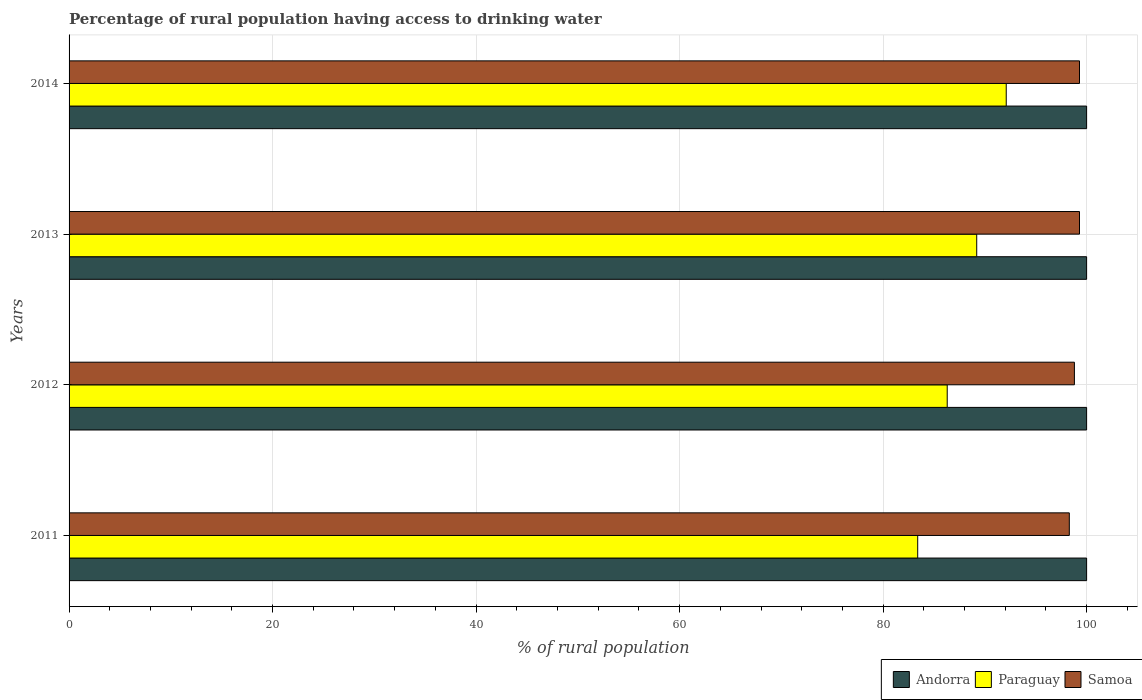How many different coloured bars are there?
Your response must be concise. 3. Are the number of bars per tick equal to the number of legend labels?
Your answer should be compact. Yes. How many bars are there on the 4th tick from the bottom?
Provide a short and direct response. 3. In how many cases, is the number of bars for a given year not equal to the number of legend labels?
Offer a very short reply. 0. What is the percentage of rural population having access to drinking water in Samoa in 2014?
Your answer should be very brief. 99.3. Across all years, what is the maximum percentage of rural population having access to drinking water in Samoa?
Ensure brevity in your answer.  99.3. Across all years, what is the minimum percentage of rural population having access to drinking water in Samoa?
Provide a succinct answer. 98.3. In which year was the percentage of rural population having access to drinking water in Andorra maximum?
Make the answer very short. 2011. What is the total percentage of rural population having access to drinking water in Samoa in the graph?
Your answer should be very brief. 395.7. What is the difference between the percentage of rural population having access to drinking water in Samoa in 2011 and the percentage of rural population having access to drinking water in Andorra in 2014?
Offer a terse response. -1.7. In the year 2011, what is the difference between the percentage of rural population having access to drinking water in Andorra and percentage of rural population having access to drinking water in Samoa?
Your answer should be very brief. 1.7. What is the ratio of the percentage of rural population having access to drinking water in Samoa in 2013 to that in 2014?
Provide a succinct answer. 1. Is the percentage of rural population having access to drinking water in Samoa in 2011 less than that in 2012?
Keep it short and to the point. Yes. Is the difference between the percentage of rural population having access to drinking water in Andorra in 2012 and 2014 greater than the difference between the percentage of rural population having access to drinking water in Samoa in 2012 and 2014?
Provide a short and direct response. Yes. What is the difference between the highest and the second highest percentage of rural population having access to drinking water in Paraguay?
Provide a short and direct response. 2.9. In how many years, is the percentage of rural population having access to drinking water in Paraguay greater than the average percentage of rural population having access to drinking water in Paraguay taken over all years?
Make the answer very short. 2. Is the sum of the percentage of rural population having access to drinking water in Samoa in 2011 and 2012 greater than the maximum percentage of rural population having access to drinking water in Paraguay across all years?
Your response must be concise. Yes. What does the 1st bar from the top in 2013 represents?
Provide a short and direct response. Samoa. What does the 2nd bar from the bottom in 2011 represents?
Offer a very short reply. Paraguay. What is the difference between two consecutive major ticks on the X-axis?
Provide a short and direct response. 20. Are the values on the major ticks of X-axis written in scientific E-notation?
Your response must be concise. No. What is the title of the graph?
Your answer should be compact. Percentage of rural population having access to drinking water. Does "Haiti" appear as one of the legend labels in the graph?
Your answer should be very brief. No. What is the label or title of the X-axis?
Give a very brief answer. % of rural population. What is the label or title of the Y-axis?
Your answer should be compact. Years. What is the % of rural population in Paraguay in 2011?
Provide a short and direct response. 83.4. What is the % of rural population in Samoa in 2011?
Provide a succinct answer. 98.3. What is the % of rural population in Andorra in 2012?
Offer a terse response. 100. What is the % of rural population of Paraguay in 2012?
Keep it short and to the point. 86.3. What is the % of rural population in Samoa in 2012?
Your answer should be compact. 98.8. What is the % of rural population of Andorra in 2013?
Your response must be concise. 100. What is the % of rural population of Paraguay in 2013?
Offer a terse response. 89.2. What is the % of rural population in Samoa in 2013?
Offer a terse response. 99.3. What is the % of rural population in Paraguay in 2014?
Your answer should be compact. 92.1. What is the % of rural population of Samoa in 2014?
Provide a short and direct response. 99.3. Across all years, what is the maximum % of rural population in Paraguay?
Offer a terse response. 92.1. Across all years, what is the maximum % of rural population of Samoa?
Give a very brief answer. 99.3. Across all years, what is the minimum % of rural population in Andorra?
Keep it short and to the point. 100. Across all years, what is the minimum % of rural population of Paraguay?
Keep it short and to the point. 83.4. Across all years, what is the minimum % of rural population of Samoa?
Provide a succinct answer. 98.3. What is the total % of rural population in Paraguay in the graph?
Your response must be concise. 351. What is the total % of rural population in Samoa in the graph?
Provide a short and direct response. 395.7. What is the difference between the % of rural population in Samoa in 2011 and that in 2012?
Offer a very short reply. -0.5. What is the difference between the % of rural population of Andorra in 2011 and that in 2013?
Your answer should be compact. 0. What is the difference between the % of rural population in Samoa in 2011 and that in 2013?
Ensure brevity in your answer.  -1. What is the difference between the % of rural population in Andorra in 2011 and that in 2014?
Your response must be concise. 0. What is the difference between the % of rural population of Paraguay in 2012 and that in 2013?
Your response must be concise. -2.9. What is the difference between the % of rural population of Samoa in 2013 and that in 2014?
Provide a short and direct response. 0. What is the difference between the % of rural population of Paraguay in 2011 and the % of rural population of Samoa in 2012?
Your response must be concise. -15.4. What is the difference between the % of rural population of Paraguay in 2011 and the % of rural population of Samoa in 2013?
Your response must be concise. -15.9. What is the difference between the % of rural population in Andorra in 2011 and the % of rural population in Paraguay in 2014?
Offer a terse response. 7.9. What is the difference between the % of rural population of Andorra in 2011 and the % of rural population of Samoa in 2014?
Offer a very short reply. 0.7. What is the difference between the % of rural population of Paraguay in 2011 and the % of rural population of Samoa in 2014?
Your response must be concise. -15.9. What is the difference between the % of rural population in Andorra in 2012 and the % of rural population in Paraguay in 2013?
Ensure brevity in your answer.  10.8. What is the difference between the % of rural population of Andorra in 2012 and the % of rural population of Samoa in 2013?
Offer a very short reply. 0.7. What is the difference between the % of rural population of Paraguay in 2012 and the % of rural population of Samoa in 2013?
Make the answer very short. -13. What is the difference between the % of rural population in Andorra in 2012 and the % of rural population in Paraguay in 2014?
Make the answer very short. 7.9. What is the difference between the % of rural population in Andorra in 2012 and the % of rural population in Samoa in 2014?
Ensure brevity in your answer.  0.7. What is the difference between the % of rural population of Paraguay in 2012 and the % of rural population of Samoa in 2014?
Your response must be concise. -13. What is the difference between the % of rural population in Andorra in 2013 and the % of rural population in Paraguay in 2014?
Your answer should be compact. 7.9. What is the difference between the % of rural population in Andorra in 2013 and the % of rural population in Samoa in 2014?
Your response must be concise. 0.7. What is the average % of rural population of Andorra per year?
Ensure brevity in your answer.  100. What is the average % of rural population in Paraguay per year?
Keep it short and to the point. 87.75. What is the average % of rural population in Samoa per year?
Make the answer very short. 98.92. In the year 2011, what is the difference between the % of rural population in Andorra and % of rural population in Paraguay?
Keep it short and to the point. 16.6. In the year 2011, what is the difference between the % of rural population in Paraguay and % of rural population in Samoa?
Your answer should be very brief. -14.9. In the year 2012, what is the difference between the % of rural population of Andorra and % of rural population of Paraguay?
Provide a short and direct response. 13.7. In the year 2012, what is the difference between the % of rural population of Andorra and % of rural population of Samoa?
Your answer should be very brief. 1.2. In the year 2013, what is the difference between the % of rural population of Andorra and % of rural population of Paraguay?
Provide a succinct answer. 10.8. In the year 2013, what is the difference between the % of rural population of Andorra and % of rural population of Samoa?
Keep it short and to the point. 0.7. In the year 2013, what is the difference between the % of rural population of Paraguay and % of rural population of Samoa?
Make the answer very short. -10.1. In the year 2014, what is the difference between the % of rural population in Andorra and % of rural population in Paraguay?
Keep it short and to the point. 7.9. In the year 2014, what is the difference between the % of rural population in Paraguay and % of rural population in Samoa?
Offer a very short reply. -7.2. What is the ratio of the % of rural population of Andorra in 2011 to that in 2012?
Offer a terse response. 1. What is the ratio of the % of rural population of Paraguay in 2011 to that in 2012?
Give a very brief answer. 0.97. What is the ratio of the % of rural population in Andorra in 2011 to that in 2013?
Provide a succinct answer. 1. What is the ratio of the % of rural population in Paraguay in 2011 to that in 2013?
Ensure brevity in your answer.  0.94. What is the ratio of the % of rural population of Paraguay in 2011 to that in 2014?
Offer a very short reply. 0.91. What is the ratio of the % of rural population of Samoa in 2011 to that in 2014?
Your answer should be very brief. 0.99. What is the ratio of the % of rural population in Paraguay in 2012 to that in 2013?
Offer a very short reply. 0.97. What is the ratio of the % of rural population of Samoa in 2012 to that in 2013?
Your response must be concise. 0.99. What is the ratio of the % of rural population of Paraguay in 2012 to that in 2014?
Your answer should be compact. 0.94. What is the ratio of the % of rural population in Andorra in 2013 to that in 2014?
Offer a terse response. 1. What is the ratio of the % of rural population in Paraguay in 2013 to that in 2014?
Offer a terse response. 0.97. What is the ratio of the % of rural population of Samoa in 2013 to that in 2014?
Keep it short and to the point. 1. What is the difference between the highest and the second highest % of rural population of Samoa?
Give a very brief answer. 0. What is the difference between the highest and the lowest % of rural population in Paraguay?
Offer a very short reply. 8.7. What is the difference between the highest and the lowest % of rural population of Samoa?
Your response must be concise. 1. 